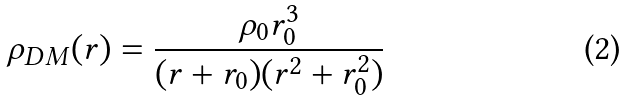Convert formula to latex. <formula><loc_0><loc_0><loc_500><loc_500>\rho _ { D M } ( r ) = \frac { \rho _ { 0 } r _ { 0 } ^ { 3 } } { ( r + r _ { 0 } ) ( r ^ { 2 } + r _ { 0 } ^ { 2 } ) }</formula> 